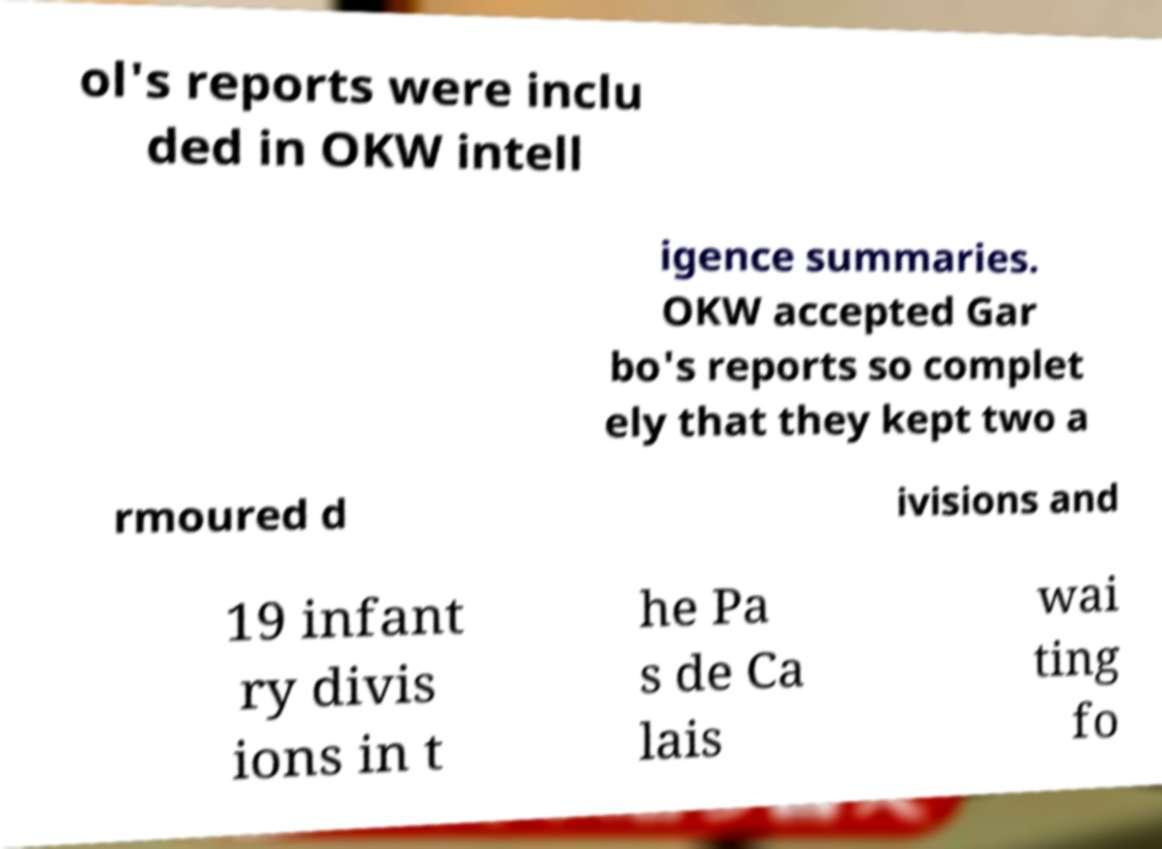I need the written content from this picture converted into text. Can you do that? ol's reports were inclu ded in OKW intell igence summaries. OKW accepted Gar bo's reports so complet ely that they kept two a rmoured d ivisions and 19 infant ry divis ions in t he Pa s de Ca lais wai ting fo 